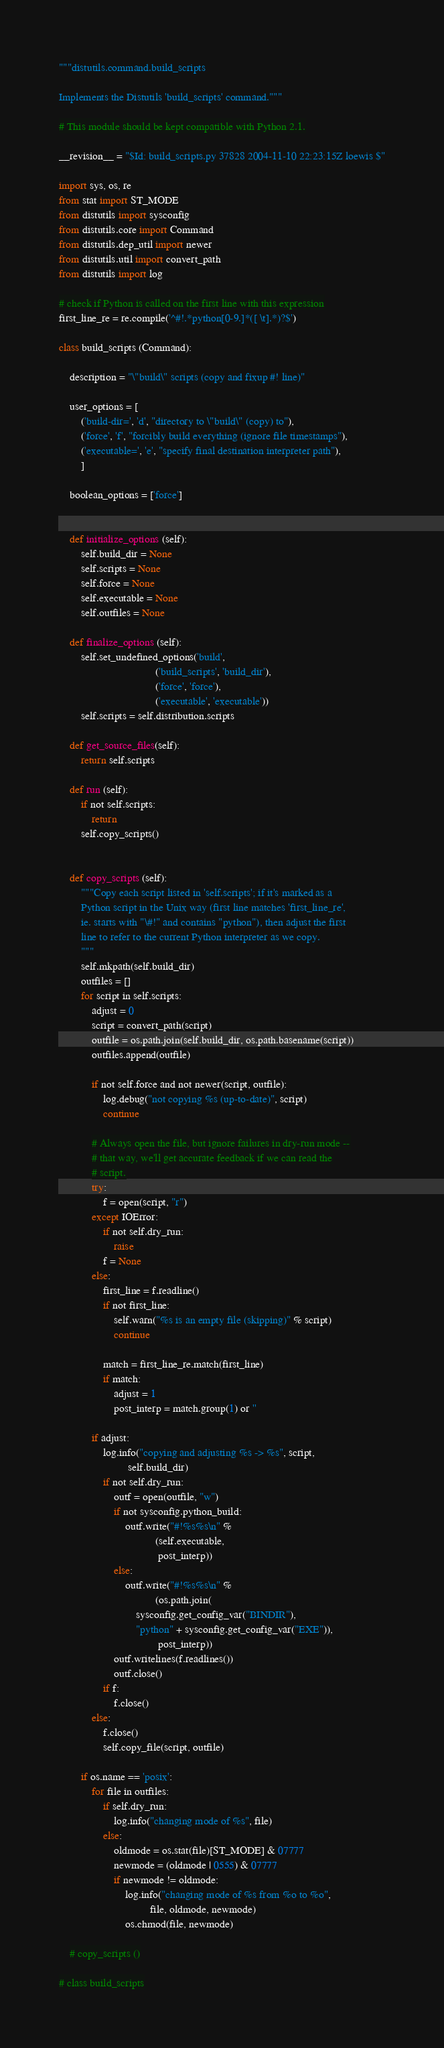Convert code to text. <code><loc_0><loc_0><loc_500><loc_500><_Python_>"""distutils.command.build_scripts

Implements the Distutils 'build_scripts' command."""

# This module should be kept compatible with Python 2.1.

__revision__ = "$Id: build_scripts.py 37828 2004-11-10 22:23:15Z loewis $"

import sys, os, re
from stat import ST_MODE
from distutils import sysconfig
from distutils.core import Command
from distutils.dep_util import newer
from distutils.util import convert_path
from distutils import log

# check if Python is called on the first line with this expression
first_line_re = re.compile('^#!.*python[0-9.]*([ \t].*)?$')

class build_scripts (Command):

    description = "\"build\" scripts (copy and fixup #! line)"

    user_options = [
        ('build-dir=', 'd', "directory to \"build\" (copy) to"),
        ('force', 'f', "forcibly build everything (ignore file timestamps"),
        ('executable=', 'e', "specify final destination interpreter path"),
        ]

    boolean_options = ['force']


    def initialize_options (self):
        self.build_dir = None
        self.scripts = None
        self.force = None
        self.executable = None
        self.outfiles = None

    def finalize_options (self):
        self.set_undefined_options('build',
                                   ('build_scripts', 'build_dir'),
                                   ('force', 'force'),
                                   ('executable', 'executable'))
        self.scripts = self.distribution.scripts

    def get_source_files(self):
        return self.scripts

    def run (self):
        if not self.scripts:
            return
        self.copy_scripts()


    def copy_scripts (self):
        """Copy each script listed in 'self.scripts'; if it's marked as a
        Python script in the Unix way (first line matches 'first_line_re',
        ie. starts with "\#!" and contains "python"), then adjust the first
        line to refer to the current Python interpreter as we copy.
        """
        self.mkpath(self.build_dir)
        outfiles = []
        for script in self.scripts:
            adjust = 0
            script = convert_path(script)
            outfile = os.path.join(self.build_dir, os.path.basename(script))
            outfiles.append(outfile)

            if not self.force and not newer(script, outfile):
                log.debug("not copying %s (up-to-date)", script)
                continue

            # Always open the file, but ignore failures in dry-run mode --
            # that way, we'll get accurate feedback if we can read the
            # script.
            try:
                f = open(script, "r")
            except IOError:
                if not self.dry_run:
                    raise
                f = None
            else:
                first_line = f.readline()
                if not first_line:
                    self.warn("%s is an empty file (skipping)" % script)
                    continue

                match = first_line_re.match(first_line)
                if match:
                    adjust = 1
                    post_interp = match.group(1) or ''

            if adjust:
                log.info("copying and adjusting %s -> %s", script,
                         self.build_dir)
                if not self.dry_run:
                    outf = open(outfile, "w")
                    if not sysconfig.python_build:
                        outf.write("#!%s%s\n" %
                                   (self.executable,
                                    post_interp))
                    else:
                        outf.write("#!%s%s\n" %
                                   (os.path.join(
                            sysconfig.get_config_var("BINDIR"),
                            "python" + sysconfig.get_config_var("EXE")),
                                    post_interp))
                    outf.writelines(f.readlines())
                    outf.close()
                if f:
                    f.close()
            else:
                f.close()
                self.copy_file(script, outfile)

        if os.name == 'posix':
            for file in outfiles:
                if self.dry_run:
                    log.info("changing mode of %s", file)
                else:
                    oldmode = os.stat(file)[ST_MODE] & 07777
                    newmode = (oldmode | 0555) & 07777
                    if newmode != oldmode:
                        log.info("changing mode of %s from %o to %o",
                                 file, oldmode, newmode)
                        os.chmod(file, newmode)

    # copy_scripts ()

# class build_scripts
</code> 